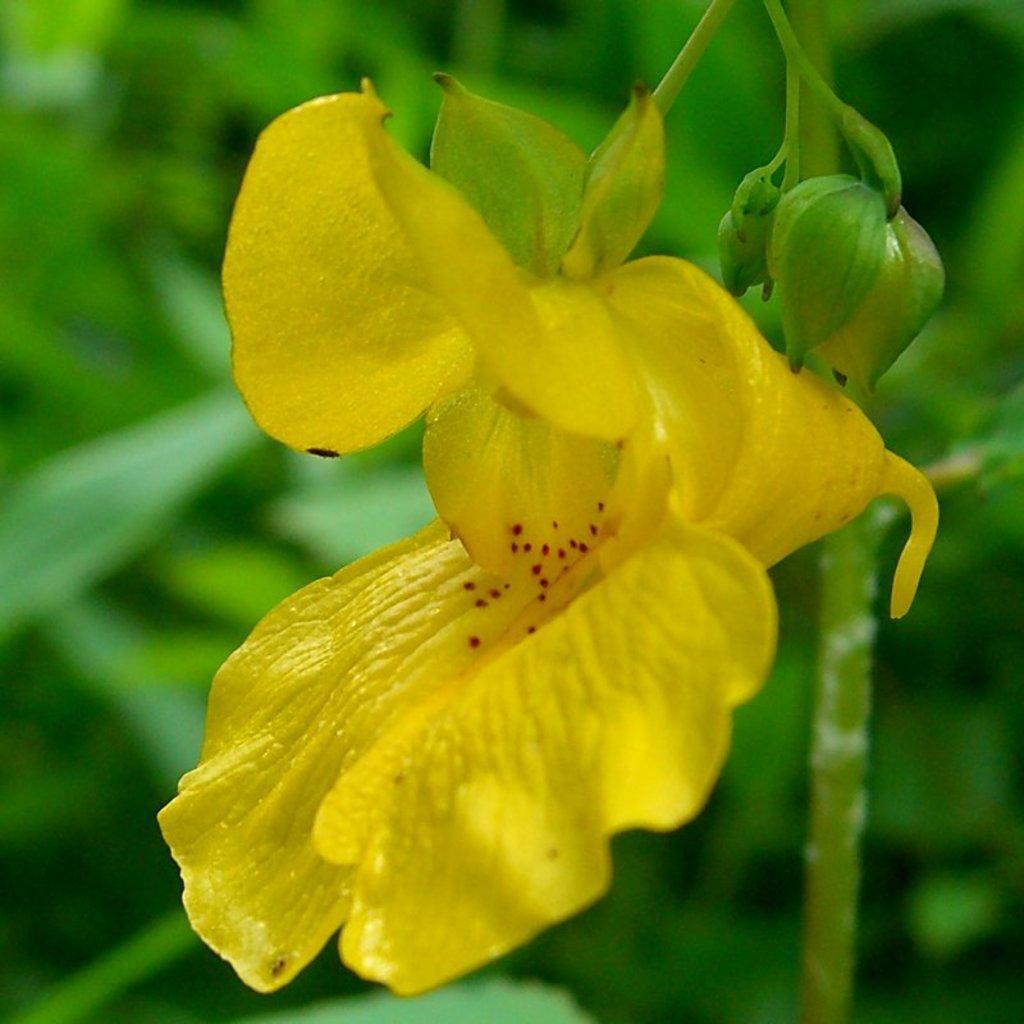Describe this image in one or two sentences. In this image I see a flower over here which is of yellow in color and I see the buds and I see the green leaves in the background and I can also see that it is blurred. 